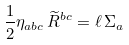<formula> <loc_0><loc_0><loc_500><loc_500>\frac { 1 } { 2 } \eta _ { a b c } \, \widetilde { R } ^ { b c } = \ell \, \Sigma _ { a }</formula> 